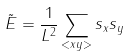<formula> <loc_0><loc_0><loc_500><loc_500>\tilde { E } = \frac { 1 } { L ^ { 2 } } \sum _ { < x y > } s _ { x } s _ { y }</formula> 